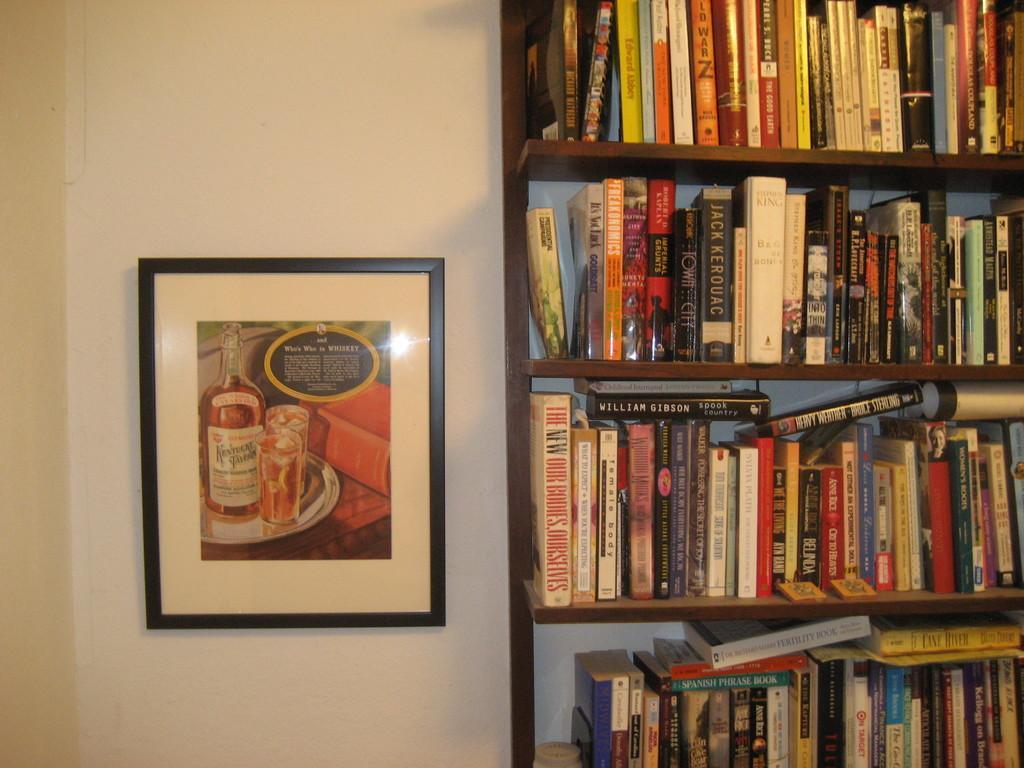Describe this image in one or two sentences. In this picture we can see few books in the racks, on the left side of the image we can see a frame on the wall. 